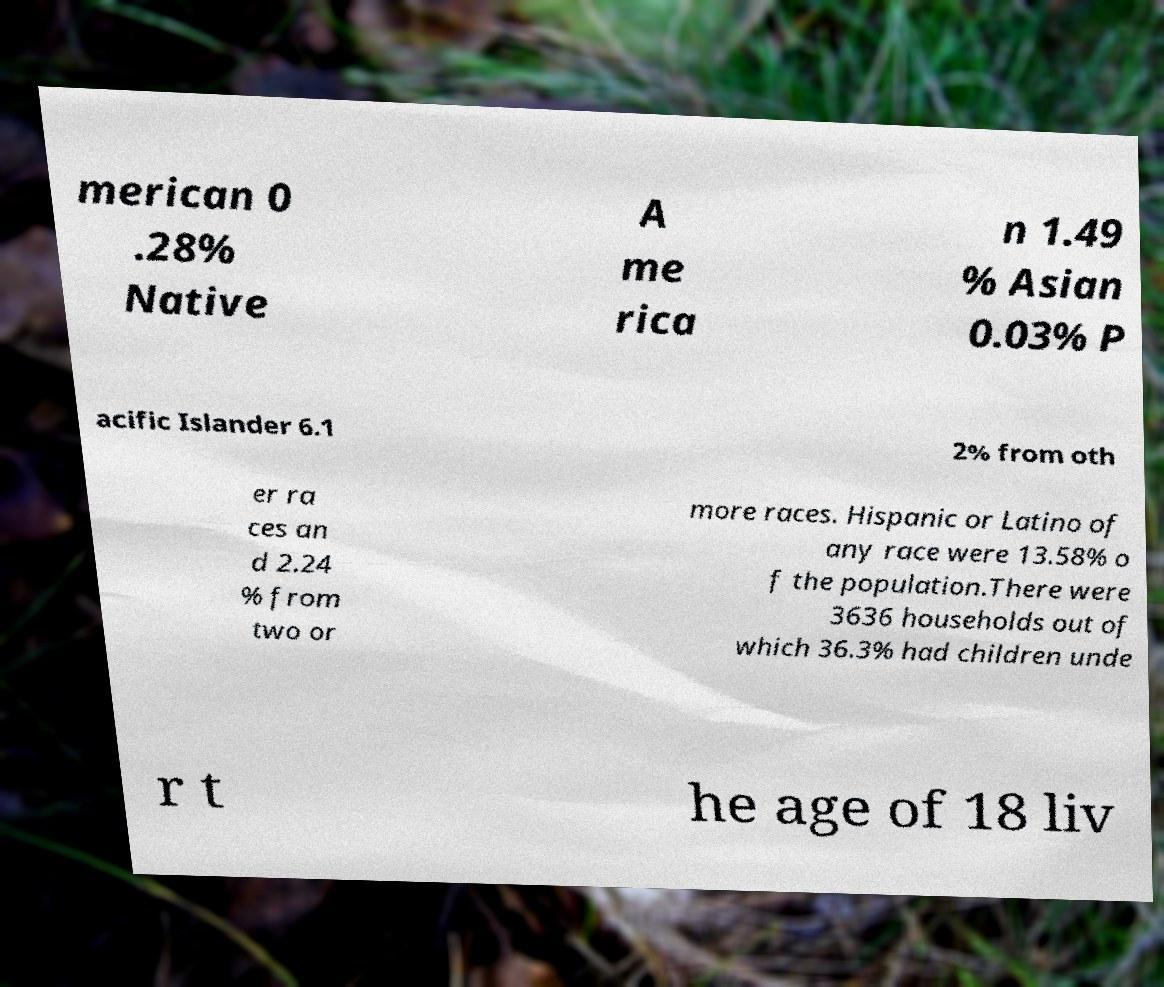There's text embedded in this image that I need extracted. Can you transcribe it verbatim? merican 0 .28% Native A me rica n 1.49 % Asian 0.03% P acific Islander 6.1 2% from oth er ra ces an d 2.24 % from two or more races. Hispanic or Latino of any race were 13.58% o f the population.There were 3636 households out of which 36.3% had children unde r t he age of 18 liv 